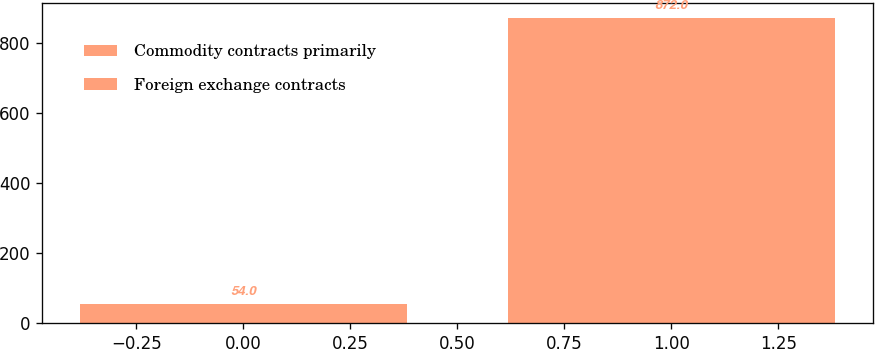Convert chart to OTSL. <chart><loc_0><loc_0><loc_500><loc_500><bar_chart><fcel>Commodity contracts primarily<fcel>Foreign exchange contracts<nl><fcel>54<fcel>872<nl></chart> 